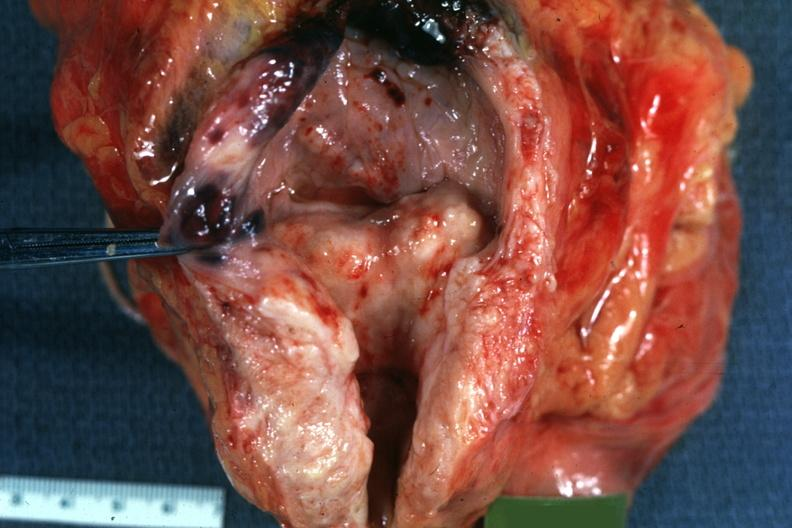s hyperplasia present?
Answer the question using a single word or phrase. Yes 